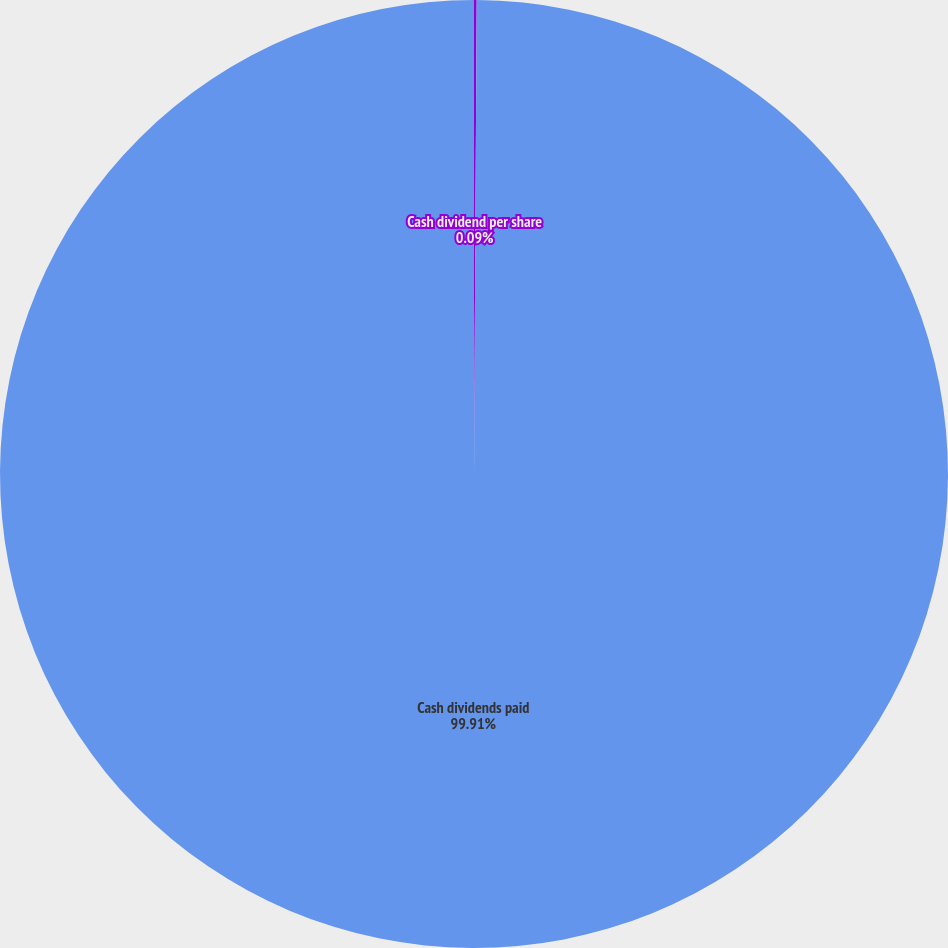Convert chart to OTSL. <chart><loc_0><loc_0><loc_500><loc_500><pie_chart><fcel>Cash dividend per share<fcel>Cash dividends paid<nl><fcel>0.09%<fcel>99.91%<nl></chart> 